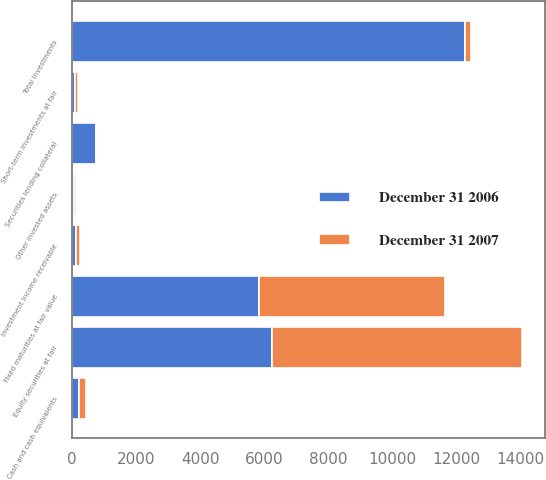Convert chart. <chart><loc_0><loc_0><loc_500><loc_500><stacked_bar_chart><ecel><fcel>Fixed maturities at fair value<fcel>Equity securities at fair<fcel>Short-term investments at fair<fcel>Other invested assets<fcel>Total investments<fcel>Cash and cash equivalents<fcel>Securities lending collateral<fcel>Investment income receivable<nl><fcel>December 31 2006<fcel>5848<fcel>6249<fcel>101<fcel>63<fcel>12261<fcel>226<fcel>760<fcel>124<nl><fcel>December 31 2007<fcel>5805<fcel>7799<fcel>95<fcel>60<fcel>202<fcel>202<fcel>0<fcel>121<nl></chart> 